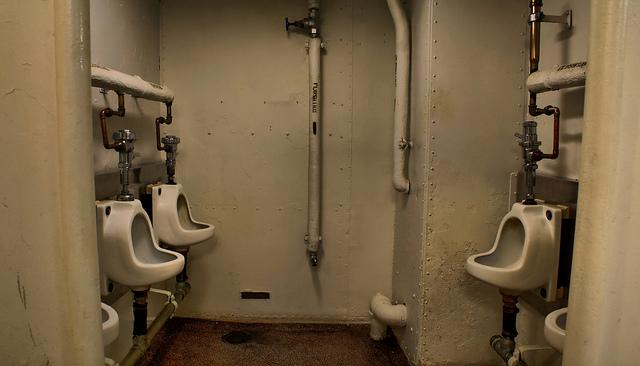What does the urinals use to wash away human waste? water 